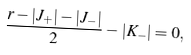Convert formula to latex. <formula><loc_0><loc_0><loc_500><loc_500>\frac { r - | J _ { + } | - | J _ { - } | } { 2 } - | K _ { - } | = 0 ,</formula> 